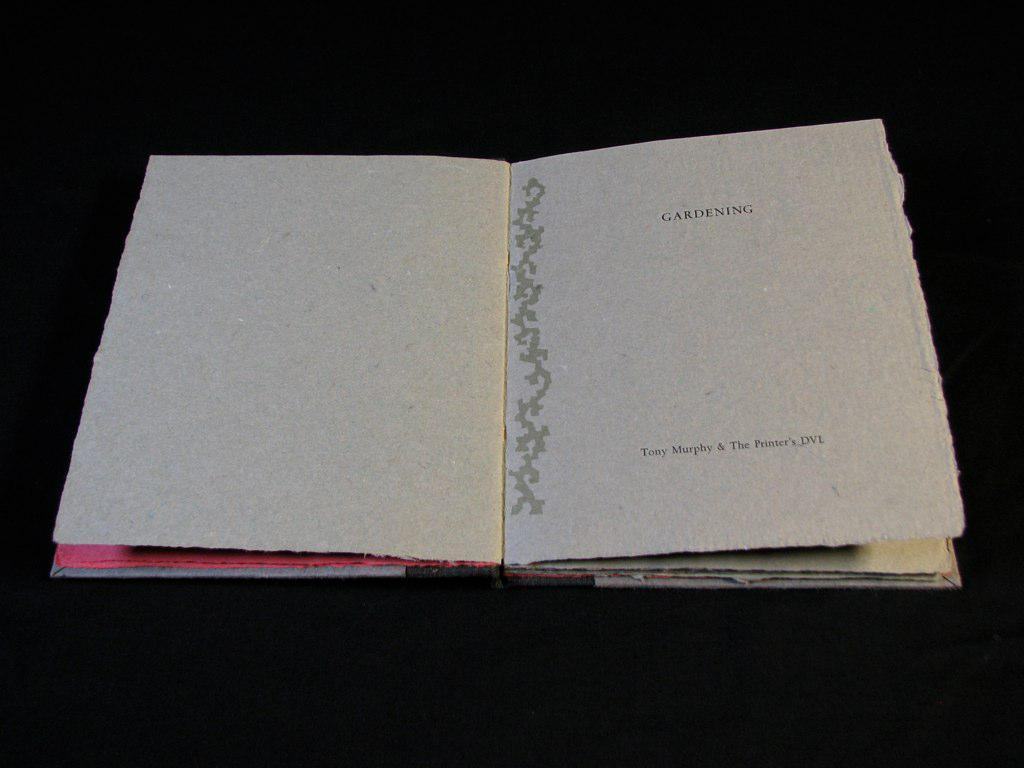<image>
Describe the image concisely. A book about Gardening sits on a black table 